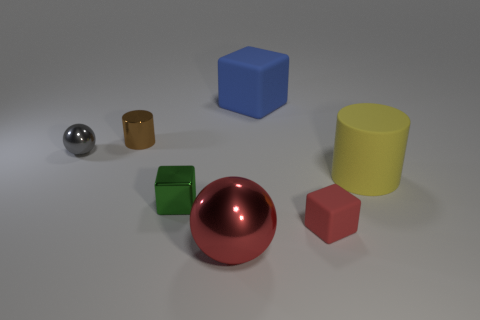Add 2 yellow matte cylinders. How many objects exist? 9 Subtract all spheres. How many objects are left? 5 Add 1 big metallic things. How many big metallic things are left? 2 Add 6 tiny purple shiny cylinders. How many tiny purple shiny cylinders exist? 6 Subtract all brown cylinders. How many cylinders are left? 1 Subtract all small red cubes. How many cubes are left? 2 Subtract 0 purple cubes. How many objects are left? 7 Subtract 1 blocks. How many blocks are left? 2 Subtract all cyan blocks. Subtract all yellow spheres. How many blocks are left? 3 Subtract all brown spheres. How many green cubes are left? 1 